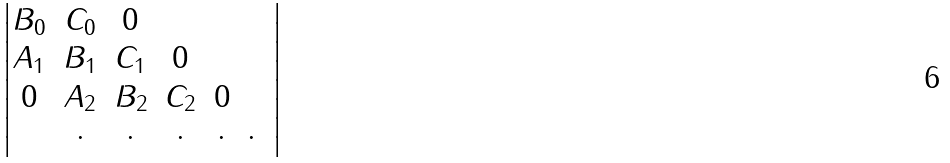Convert formula to latex. <formula><loc_0><loc_0><loc_500><loc_500>\begin{vmatrix} B _ { 0 } & C _ { 0 } & 0 & \\ A _ { 1 } & B _ { 1 } & C _ { 1 } & 0 & \\ 0 & A _ { 2 } & B _ { 2 } & C _ { 2 } & 0 & \\ & \cdot & \cdot & \cdot & \cdot & \cdot & \end{vmatrix}</formula> 